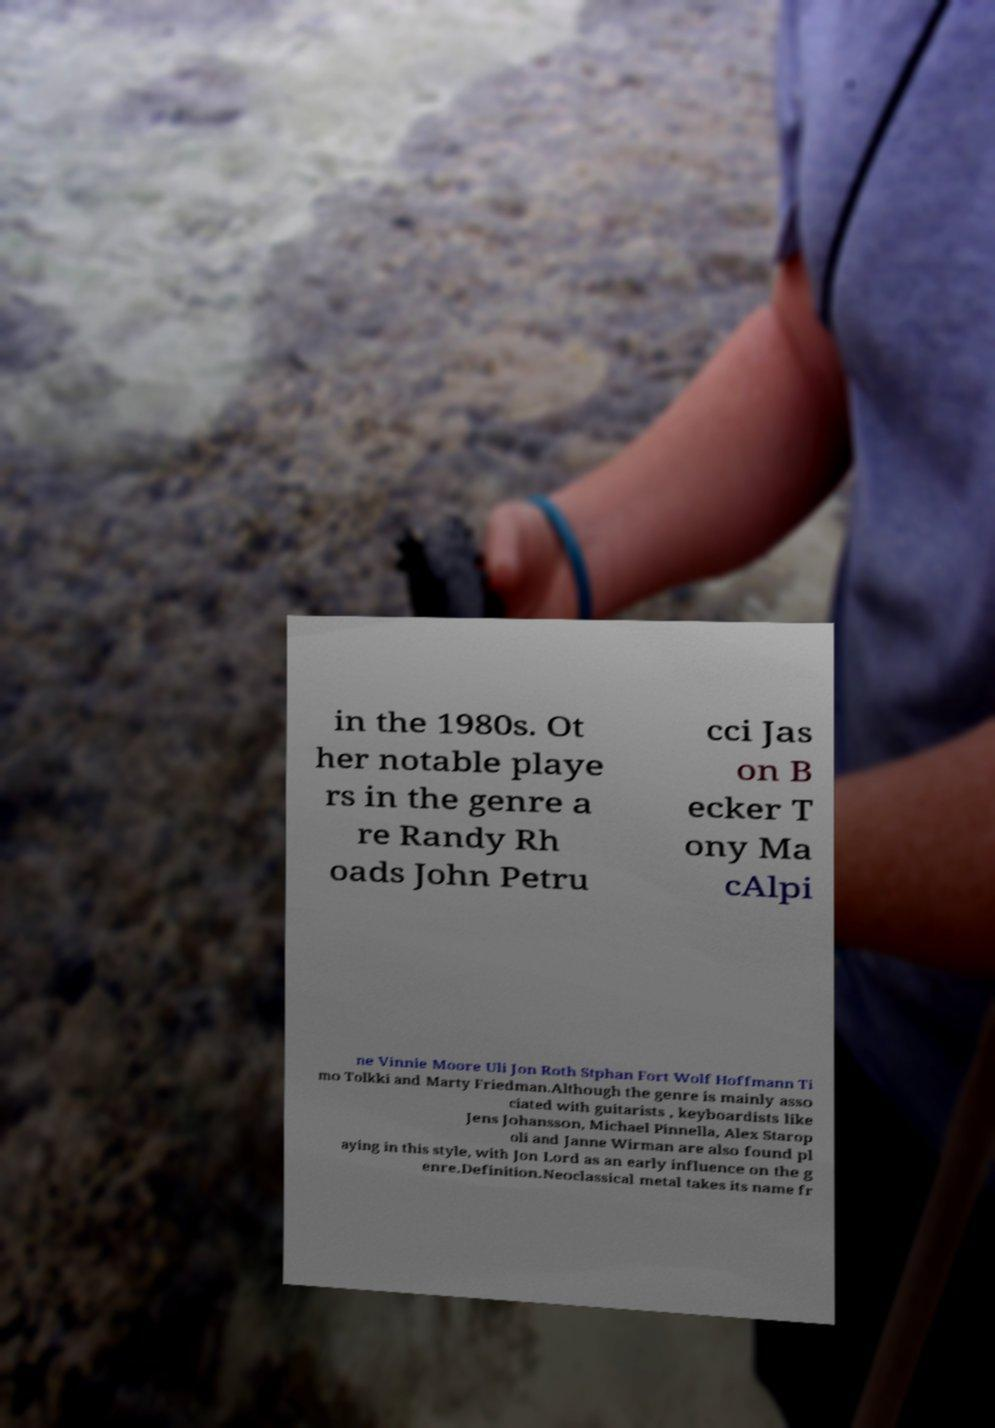Please read and relay the text visible in this image. What does it say? in the 1980s. Ot her notable playe rs in the genre a re Randy Rh oads John Petru cci Jas on B ecker T ony Ma cAlpi ne Vinnie Moore Uli Jon Roth Stphan Fort Wolf Hoffmann Ti mo Tolkki and Marty Friedman.Although the genre is mainly asso ciated with guitarists , keyboardists like Jens Johansson, Michael Pinnella, Alex Starop oli and Janne Wirman are also found pl aying in this style, with Jon Lord as an early influence on the g enre.Definition.Neoclassical metal takes its name fr 